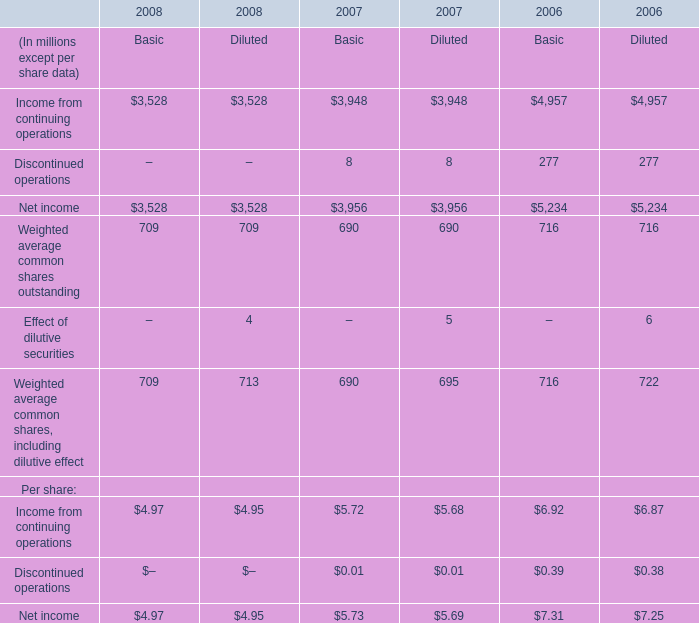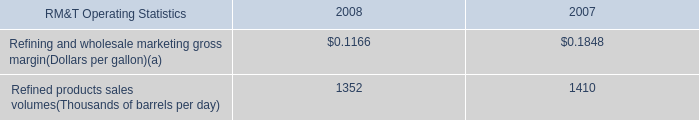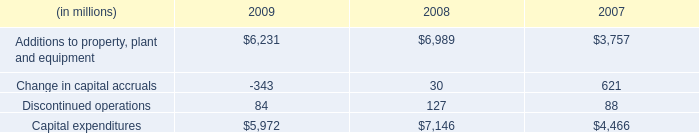What was the total amount of the Income from continuing operations in the years where Net income for Basic is greater than 5000? (in million) 
Computations: (4957 + 4957)
Answer: 9914.0. 